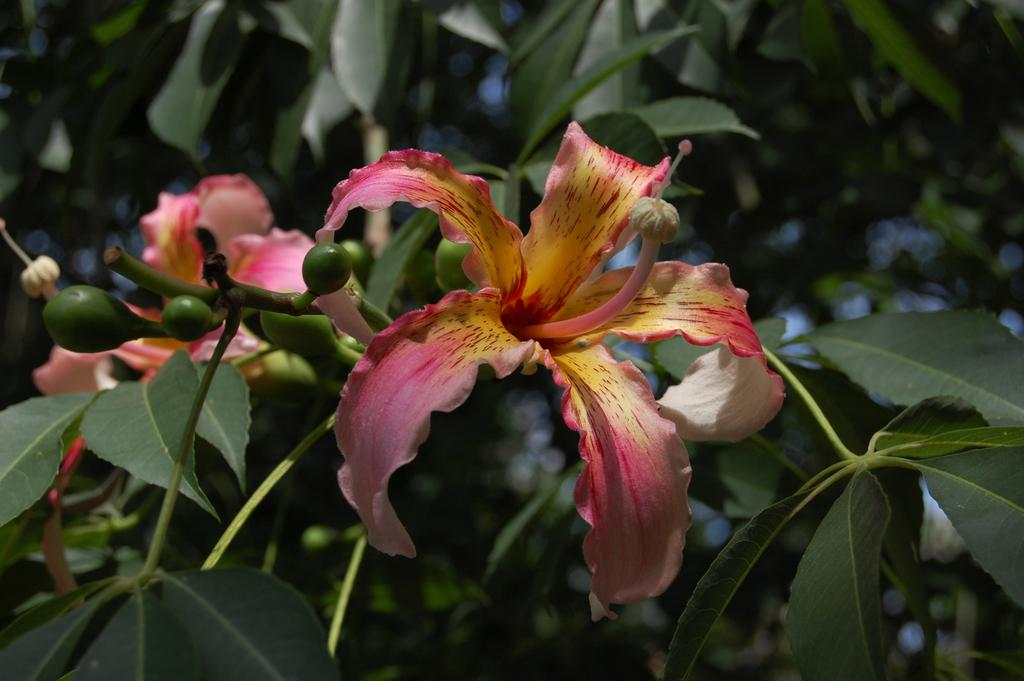What type of plants can be seen in the image? There are flowers in the image. What colors are the flowers? The flowers are in pink and yellow colors. What else can be seen in the background of the image? There are leaves in the background of the image. What color are the leaves? The leaves are in green color. How many dogs are visible in the image? There are no dogs present in the image; it features flowers and leaves. What type of cork can be seen in the image? There is no cork present in the image. 